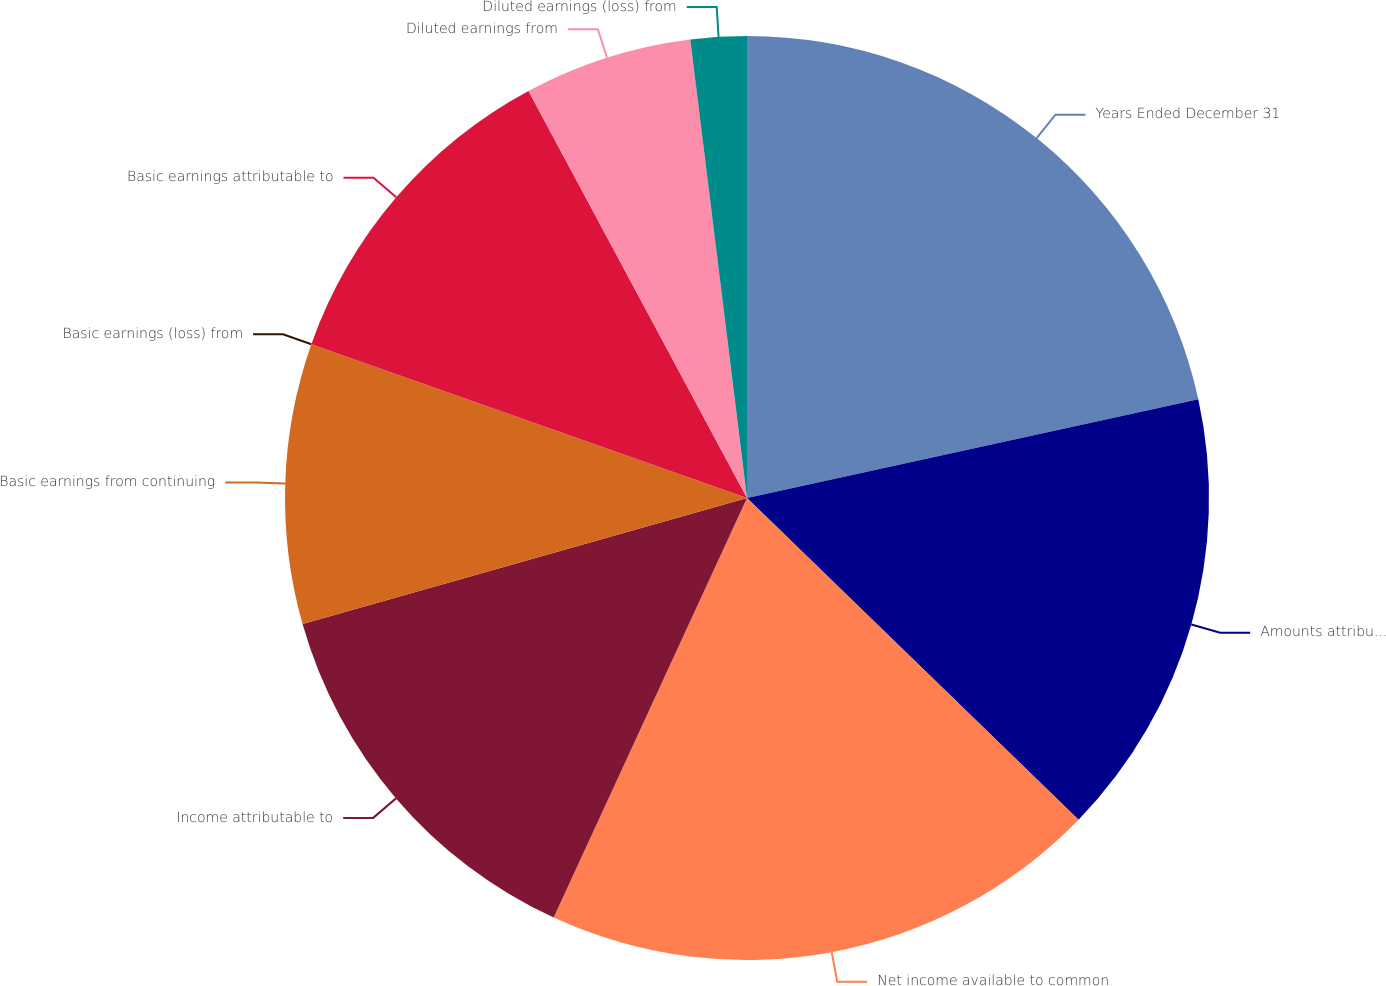<chart> <loc_0><loc_0><loc_500><loc_500><pie_chart><fcel>Years Ended December 31<fcel>Amounts attributable to<fcel>Net income available to common<fcel>Income attributable to<fcel>Basic earnings from continuing<fcel>Basic earnings (loss) from<fcel>Basic earnings attributable to<fcel>Diluted earnings from<fcel>Diluted earnings (loss) from<nl><fcel>21.57%<fcel>15.69%<fcel>19.61%<fcel>13.73%<fcel>9.8%<fcel>0.0%<fcel>11.76%<fcel>5.88%<fcel>1.96%<nl></chart> 